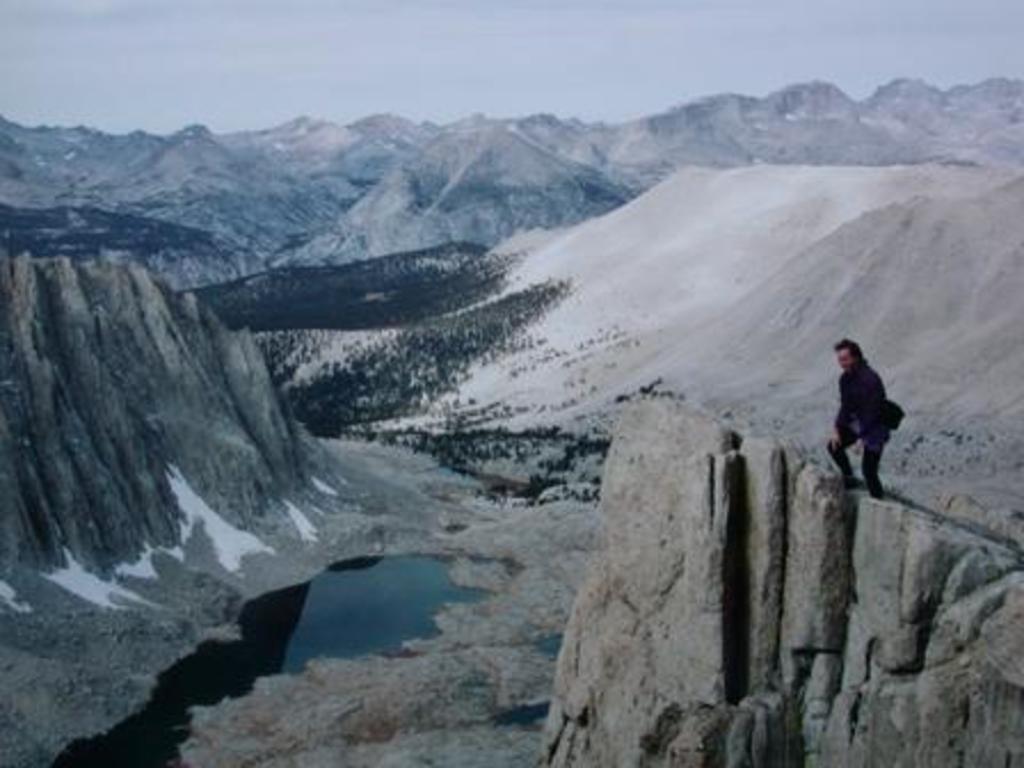Can you describe this image briefly? There is one person standing on a mountain as we can see on the right side of this image, and there are some other mountains in the background. There is a surface of water at the bottom of this image. There is a sky at the top of this image. 